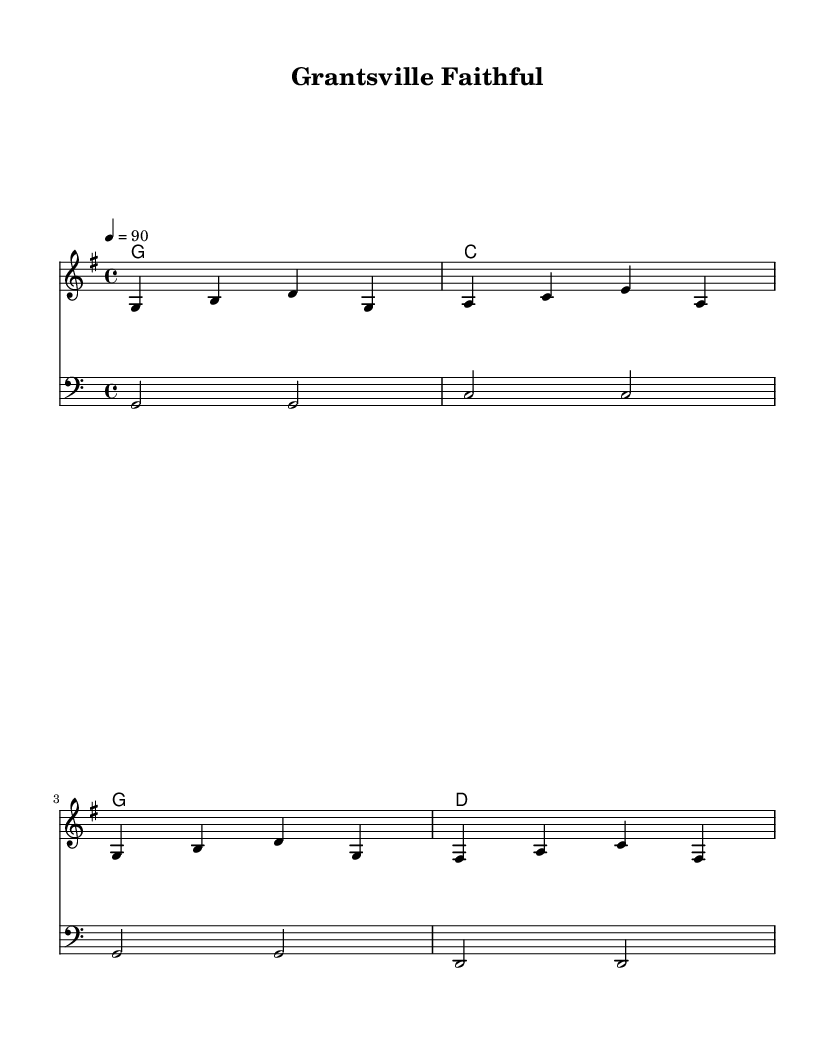What is the key signature of this music? The key signature is G major, which has one sharp (F#). This can be determined by looking at the key signature indicated at the beginning of the piece.
Answer: G major What is the time signature of this music? The time signature is 4/4, which means there are four beats in each measure and the quarter note gets one beat. This is shown at the beginning of the score.
Answer: 4/4 What is the tempo marking for this piece? The tempo is marked as 90 beats per minute. This is indicated in the tempo instruction present in the global settings of the score.
Answer: 90 What is the structure of the rap's lyrics? The lyrics reflect themes of faith and family. The text indicates a connection to rural life and values, specifically referencing the town of Grantsville and the church, which aligns with common rap themes of storytelling and personal experience.
Answer: Faith and family How many measures are in the melody? There are four measures in the melody section as indicated by the vertical lines separating the measures.
Answer: Four measures What chords are used in the harmonies? The chords used are G, C, G, and D as shown in the chord names section. These correspond to the harmonic structure of the piece.
Answer: G, C, D How does the bass line complement the melody? The bass line plays a foundational role by doubling the root notes of the chords, promoting a sense of stability and rhythm that supports the melodic line. This emphasizes the harmony and creates a fuller sound.
Answer: Complements harmony 